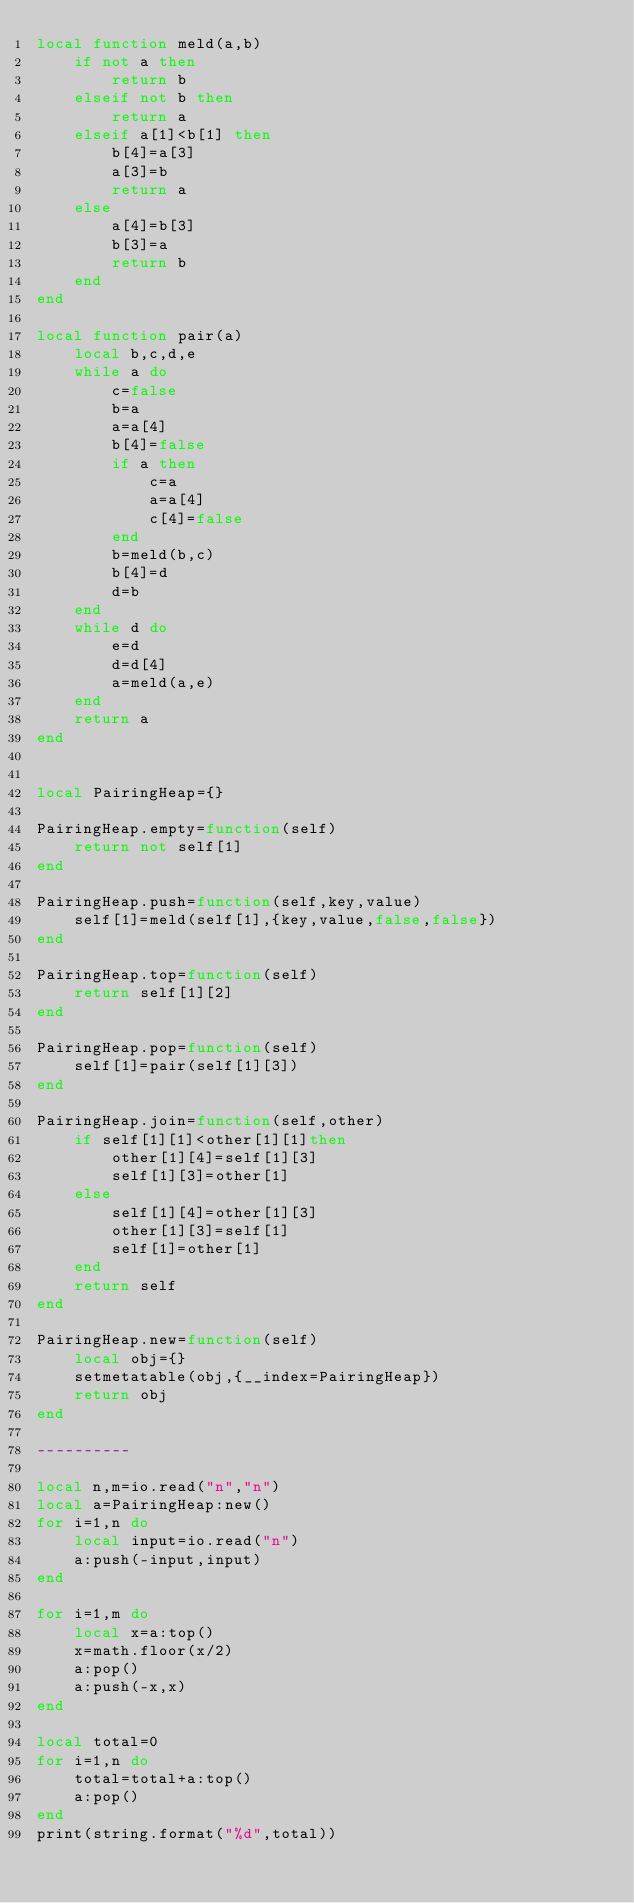Convert code to text. <code><loc_0><loc_0><loc_500><loc_500><_Lua_>local function meld(a,b)
    if not a then
        return b
    elseif not b then
        return a
    elseif a[1]<b[1] then
        b[4]=a[3]
        a[3]=b
        return a
    else
        a[4]=b[3]
        b[3]=a
        return b
    end
end

local function pair(a)
    local b,c,d,e
    while a do
        c=false
        b=a
        a=a[4]
        b[4]=false
        if a then
            c=a
            a=a[4]   
            c[4]=false
        end
        b=meld(b,c)
        b[4]=d
        d=b
    end
    while d do
        e=d
        d=d[4]
        a=meld(a,e)
    end
    return a
end


local PairingHeap={}

PairingHeap.empty=function(self)
    return not self[1]
end

PairingHeap.push=function(self,key,value)
    self[1]=meld(self[1],{key,value,false,false})
end

PairingHeap.top=function(self)
    return self[1][2]
end

PairingHeap.pop=function(self)
    self[1]=pair(self[1][3])
end

PairingHeap.join=function(self,other)
    if self[1][1]<other[1][1]then
		other[1][4]=self[1][3]
        self[1][3]=other[1]
	else
		self[1][4]=other[1][3]
        other[1][3]=self[1]
        self[1]=other[1]
    end
    return self
end

PairingHeap.new=function(self)
    local obj={}
    setmetatable(obj,{__index=PairingHeap})
    return obj
end

----------
 
local n,m=io.read("n","n")
local a=PairingHeap:new()
for i=1,n do
    local input=io.read("n")
    a:push(-input,input)
end
 
for i=1,m do
    local x=a:top()
    x=math.floor(x/2)
    a:pop()
    a:push(-x,x)
end
 
local total=0
for i=1,n do
    total=total+a:top()
    a:pop()
end
print(string.format("%d",total))</code> 